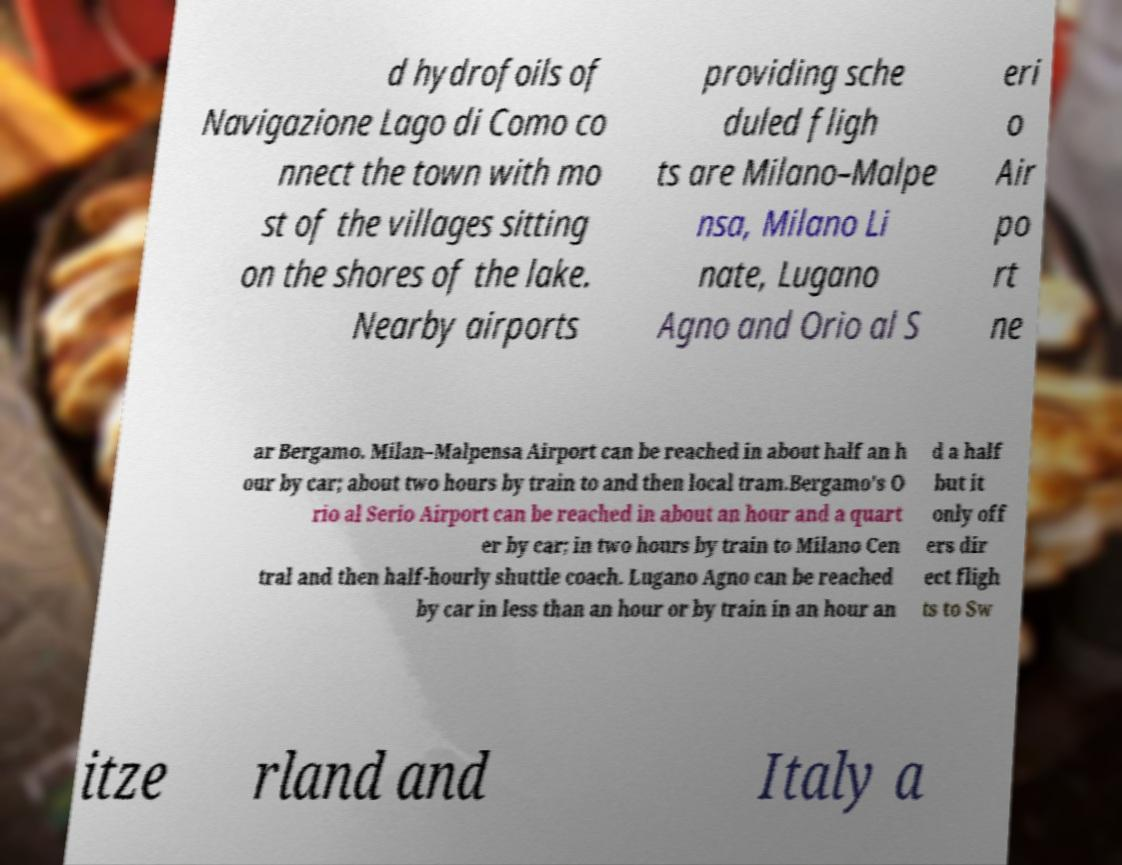Can you read and provide the text displayed in the image?This photo seems to have some interesting text. Can you extract and type it out for me? d hydrofoils of Navigazione Lago di Como co nnect the town with mo st of the villages sitting on the shores of the lake. Nearby airports providing sche duled fligh ts are Milano–Malpe nsa, Milano Li nate, Lugano Agno and Orio al S eri o Air po rt ne ar Bergamo. Milan–Malpensa Airport can be reached in about half an h our by car; about two hours by train to and then local tram.Bergamo's O rio al Serio Airport can be reached in about an hour and a quart er by car; in two hours by train to Milano Cen tral and then half-hourly shuttle coach. Lugano Agno can be reached by car in less than an hour or by train in an hour an d a half but it only off ers dir ect fligh ts to Sw itze rland and Italy a 